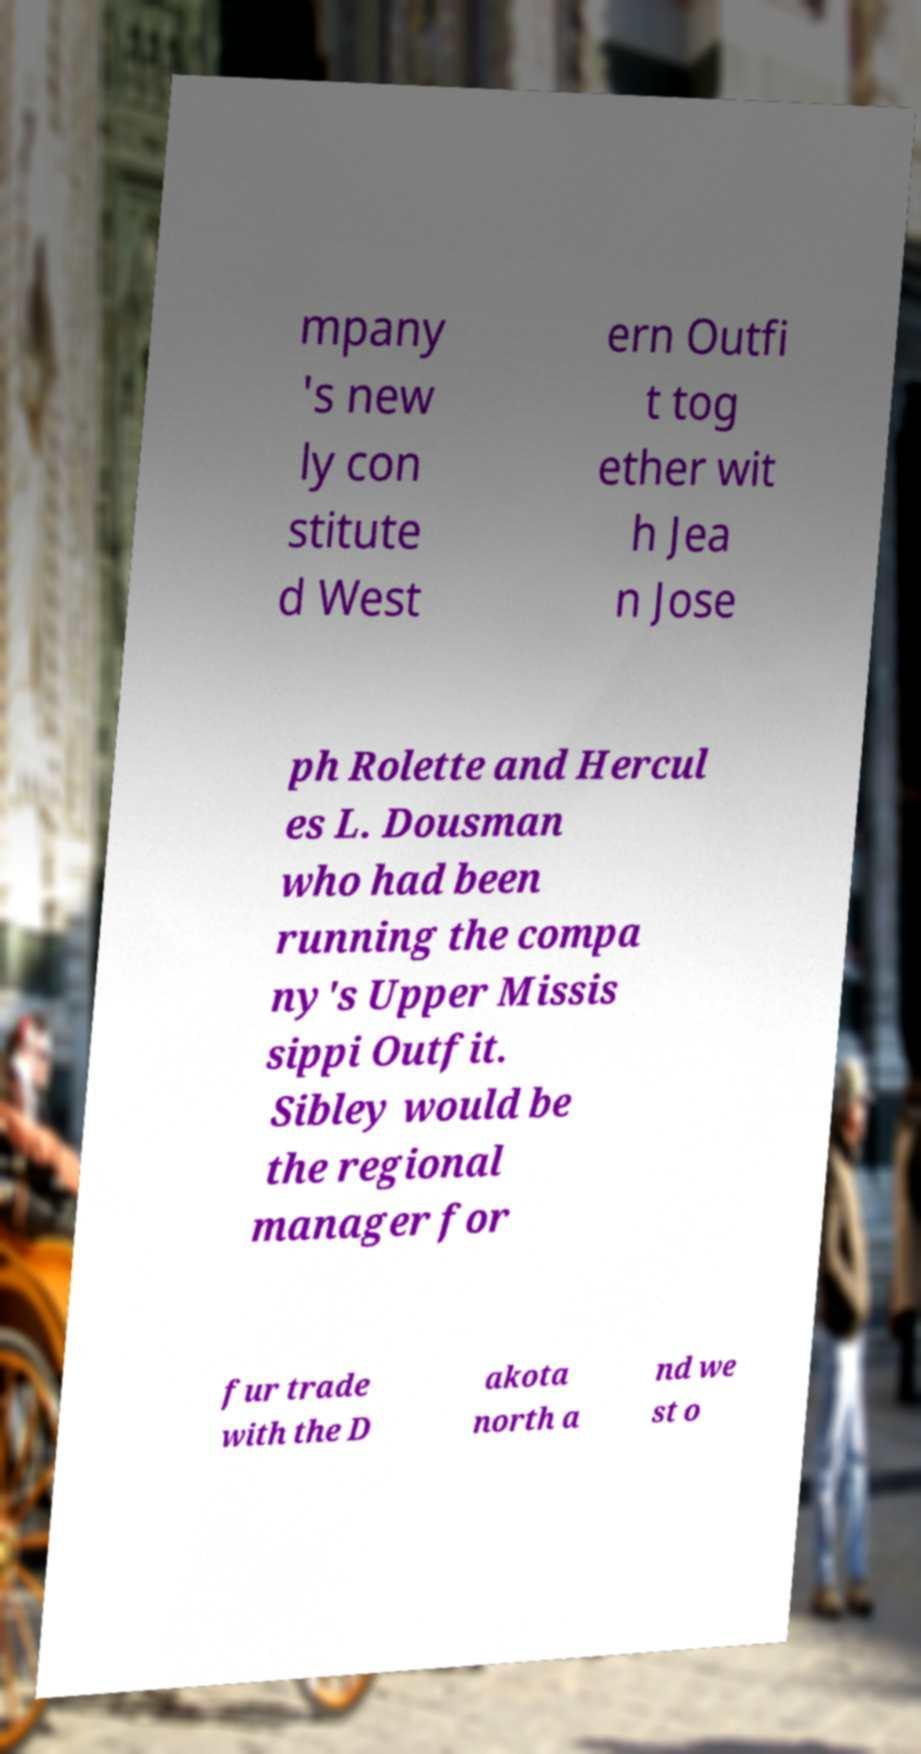There's text embedded in this image that I need extracted. Can you transcribe it verbatim? mpany 's new ly con stitute d West ern Outfi t tog ether wit h Jea n Jose ph Rolette and Hercul es L. Dousman who had been running the compa ny's Upper Missis sippi Outfit. Sibley would be the regional manager for fur trade with the D akota north a nd we st o 